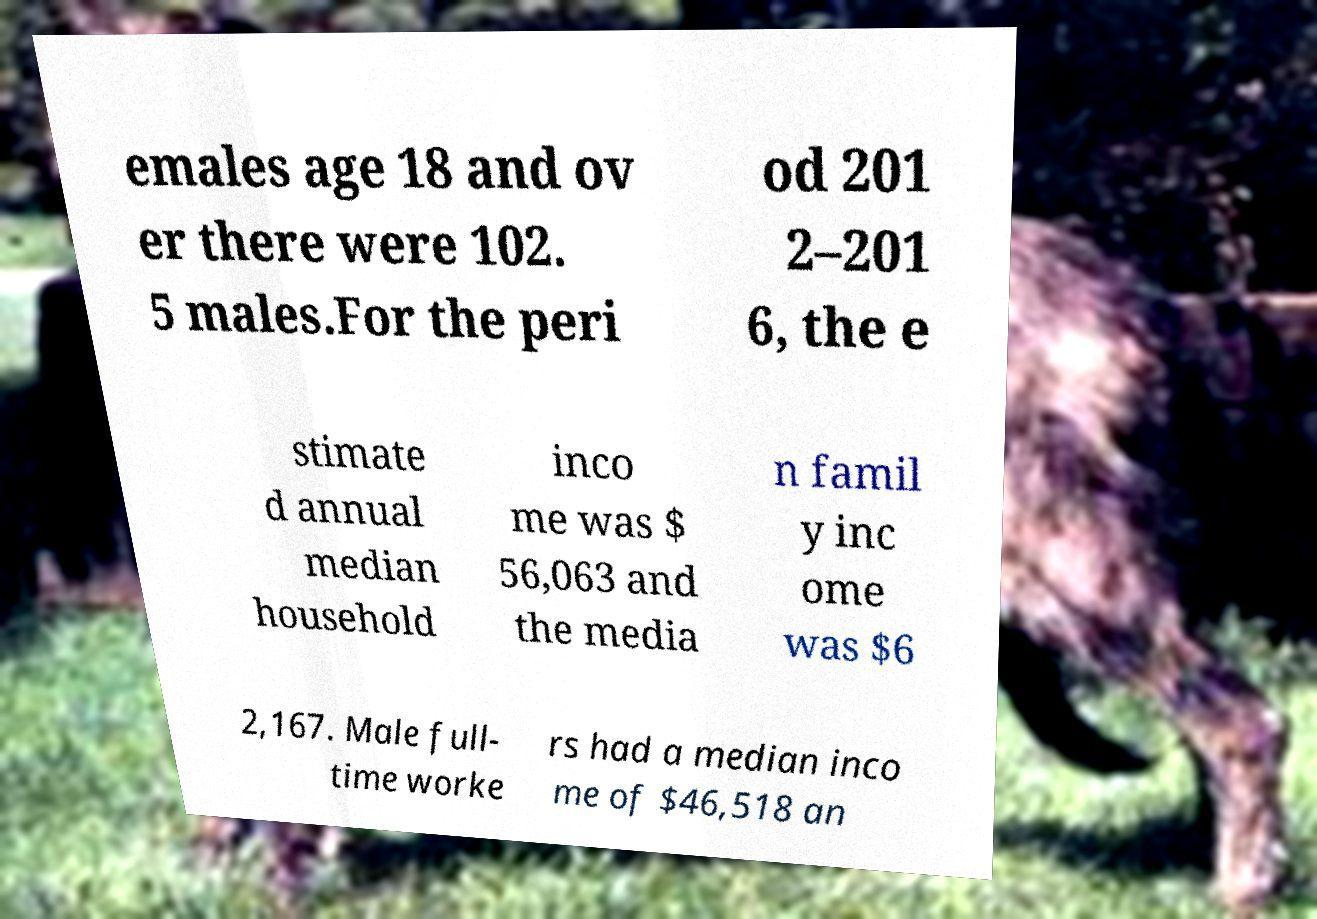Please identify and transcribe the text found in this image. emales age 18 and ov er there were 102. 5 males.For the peri od 201 2–201 6, the e stimate d annual median household inco me was $ 56,063 and the media n famil y inc ome was $6 2,167. Male full- time worke rs had a median inco me of $46,518 an 